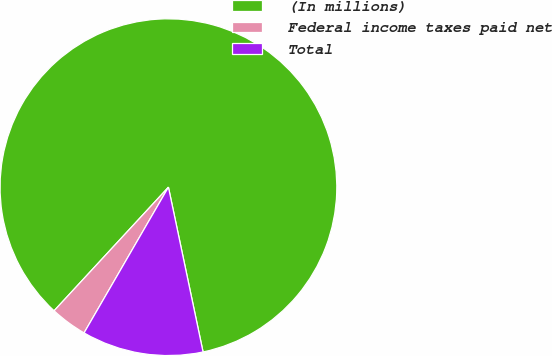Convert chart to OTSL. <chart><loc_0><loc_0><loc_500><loc_500><pie_chart><fcel>(In millions)<fcel>Federal income taxes paid net<fcel>Total<nl><fcel>84.82%<fcel>3.53%<fcel>11.65%<nl></chart> 